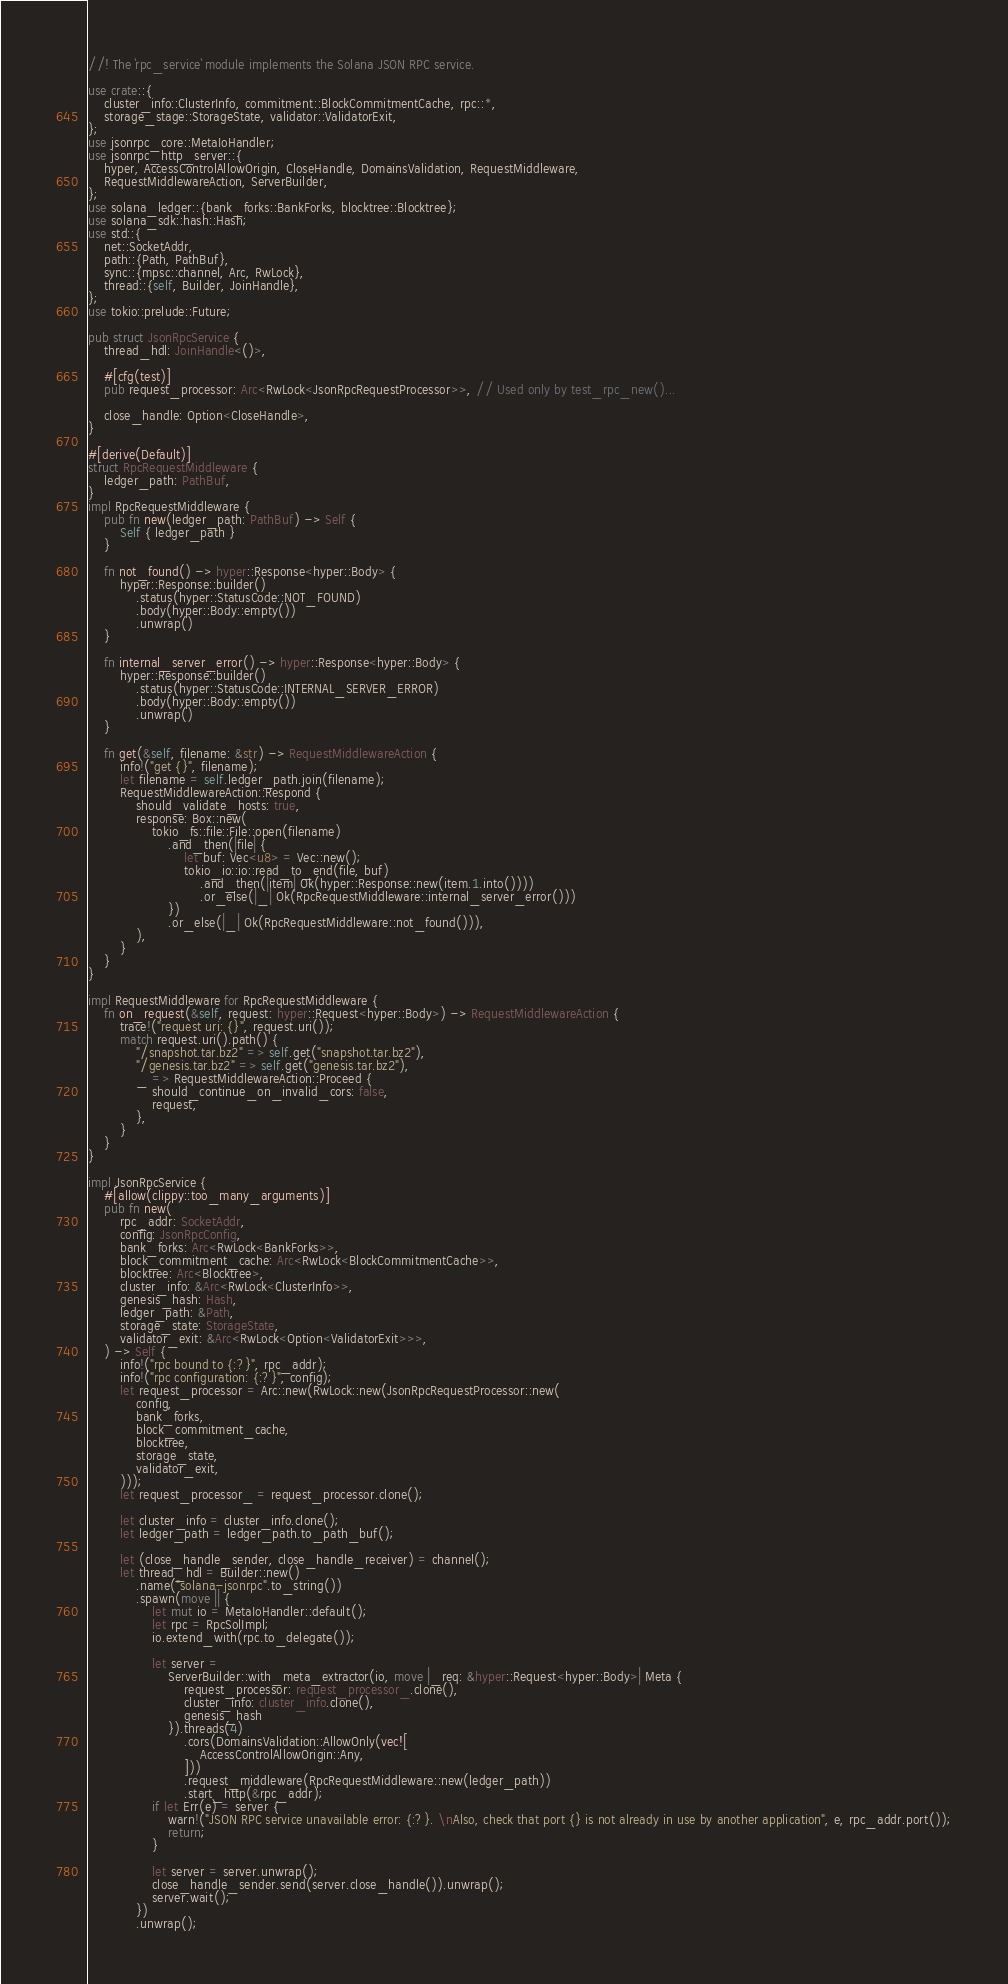<code> <loc_0><loc_0><loc_500><loc_500><_Rust_>//! The `rpc_service` module implements the Solana JSON RPC service.

use crate::{
    cluster_info::ClusterInfo, commitment::BlockCommitmentCache, rpc::*,
    storage_stage::StorageState, validator::ValidatorExit,
};
use jsonrpc_core::MetaIoHandler;
use jsonrpc_http_server::{
    hyper, AccessControlAllowOrigin, CloseHandle, DomainsValidation, RequestMiddleware,
    RequestMiddlewareAction, ServerBuilder,
};
use solana_ledger::{bank_forks::BankForks, blocktree::Blocktree};
use solana_sdk::hash::Hash;
use std::{
    net::SocketAddr,
    path::{Path, PathBuf},
    sync::{mpsc::channel, Arc, RwLock},
    thread::{self, Builder, JoinHandle},
};
use tokio::prelude::Future;

pub struct JsonRpcService {
    thread_hdl: JoinHandle<()>,

    #[cfg(test)]
    pub request_processor: Arc<RwLock<JsonRpcRequestProcessor>>, // Used only by test_rpc_new()...

    close_handle: Option<CloseHandle>,
}

#[derive(Default)]
struct RpcRequestMiddleware {
    ledger_path: PathBuf,
}
impl RpcRequestMiddleware {
    pub fn new(ledger_path: PathBuf) -> Self {
        Self { ledger_path }
    }

    fn not_found() -> hyper::Response<hyper::Body> {
        hyper::Response::builder()
            .status(hyper::StatusCode::NOT_FOUND)
            .body(hyper::Body::empty())
            .unwrap()
    }

    fn internal_server_error() -> hyper::Response<hyper::Body> {
        hyper::Response::builder()
            .status(hyper::StatusCode::INTERNAL_SERVER_ERROR)
            .body(hyper::Body::empty())
            .unwrap()
    }

    fn get(&self, filename: &str) -> RequestMiddlewareAction {
        info!("get {}", filename);
        let filename = self.ledger_path.join(filename);
        RequestMiddlewareAction::Respond {
            should_validate_hosts: true,
            response: Box::new(
                tokio_fs::file::File::open(filename)
                    .and_then(|file| {
                        let buf: Vec<u8> = Vec::new();
                        tokio_io::io::read_to_end(file, buf)
                            .and_then(|item| Ok(hyper::Response::new(item.1.into())))
                            .or_else(|_| Ok(RpcRequestMiddleware::internal_server_error()))
                    })
                    .or_else(|_| Ok(RpcRequestMiddleware::not_found())),
            ),
        }
    }
}

impl RequestMiddleware for RpcRequestMiddleware {
    fn on_request(&self, request: hyper::Request<hyper::Body>) -> RequestMiddlewareAction {
        trace!("request uri: {}", request.uri());
        match request.uri().path() {
            "/snapshot.tar.bz2" => self.get("snapshot.tar.bz2"),
            "/genesis.tar.bz2" => self.get("genesis.tar.bz2"),
            _ => RequestMiddlewareAction::Proceed {
                should_continue_on_invalid_cors: false,
                request,
            },
        }
    }
}

impl JsonRpcService {
    #[allow(clippy::too_many_arguments)]
    pub fn new(
        rpc_addr: SocketAddr,
        config: JsonRpcConfig,
        bank_forks: Arc<RwLock<BankForks>>,
        block_commitment_cache: Arc<RwLock<BlockCommitmentCache>>,
        blocktree: Arc<Blocktree>,
        cluster_info: &Arc<RwLock<ClusterInfo>>,
        genesis_hash: Hash,
        ledger_path: &Path,
        storage_state: StorageState,
        validator_exit: &Arc<RwLock<Option<ValidatorExit>>>,
    ) -> Self {
        info!("rpc bound to {:?}", rpc_addr);
        info!("rpc configuration: {:?}", config);
        let request_processor = Arc::new(RwLock::new(JsonRpcRequestProcessor::new(
            config,
            bank_forks,
            block_commitment_cache,
            blocktree,
            storage_state,
            validator_exit,
        )));
        let request_processor_ = request_processor.clone();

        let cluster_info = cluster_info.clone();
        let ledger_path = ledger_path.to_path_buf();

        let (close_handle_sender, close_handle_receiver) = channel();
        let thread_hdl = Builder::new()
            .name("solana-jsonrpc".to_string())
            .spawn(move || {
                let mut io = MetaIoHandler::default();
                let rpc = RpcSolImpl;
                io.extend_with(rpc.to_delegate());

                let server =
                    ServerBuilder::with_meta_extractor(io, move |_req: &hyper::Request<hyper::Body>| Meta {
                        request_processor: request_processor_.clone(),
                        cluster_info: cluster_info.clone(),
                        genesis_hash
                    }).threads(4)
                        .cors(DomainsValidation::AllowOnly(vec![
                            AccessControlAllowOrigin::Any,
                        ]))
                        .request_middleware(RpcRequestMiddleware::new(ledger_path))
                        .start_http(&rpc_addr);
                if let Err(e) = server {
                    warn!("JSON RPC service unavailable error: {:?}. \nAlso, check that port {} is not already in use by another application", e, rpc_addr.port());
                    return;
                }

                let server = server.unwrap();
                close_handle_sender.send(server.close_handle()).unwrap();
                server.wait();
            })
            .unwrap();
</code> 